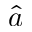Convert formula to latex. <formula><loc_0><loc_0><loc_500><loc_500>\hat { a }</formula> 